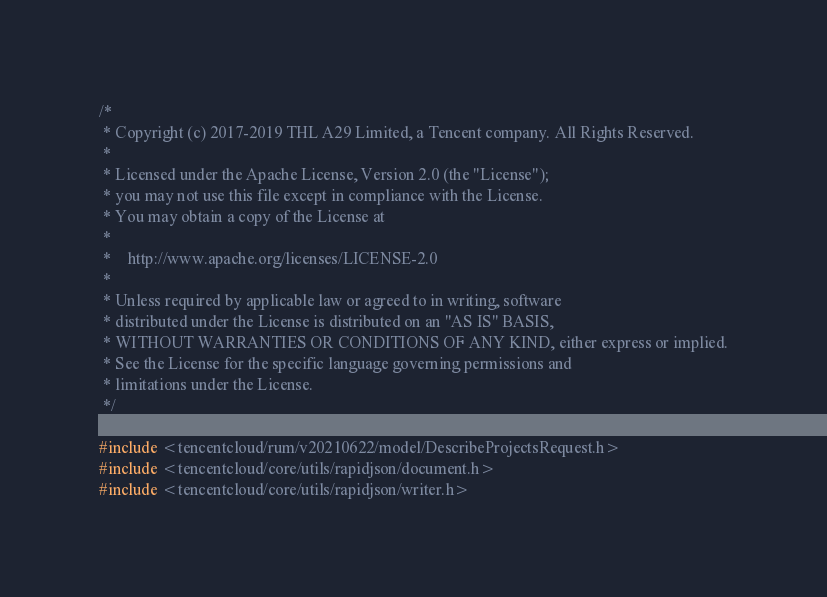Convert code to text. <code><loc_0><loc_0><loc_500><loc_500><_C++_>/*
 * Copyright (c) 2017-2019 THL A29 Limited, a Tencent company. All Rights Reserved.
 *
 * Licensed under the Apache License, Version 2.0 (the "License");
 * you may not use this file except in compliance with the License.
 * You may obtain a copy of the License at
 *
 *    http://www.apache.org/licenses/LICENSE-2.0
 *
 * Unless required by applicable law or agreed to in writing, software
 * distributed under the License is distributed on an "AS IS" BASIS,
 * WITHOUT WARRANTIES OR CONDITIONS OF ANY KIND, either express or implied.
 * See the License for the specific language governing permissions and
 * limitations under the License.
 */

#include <tencentcloud/rum/v20210622/model/DescribeProjectsRequest.h>
#include <tencentcloud/core/utils/rapidjson/document.h>
#include <tencentcloud/core/utils/rapidjson/writer.h></code> 